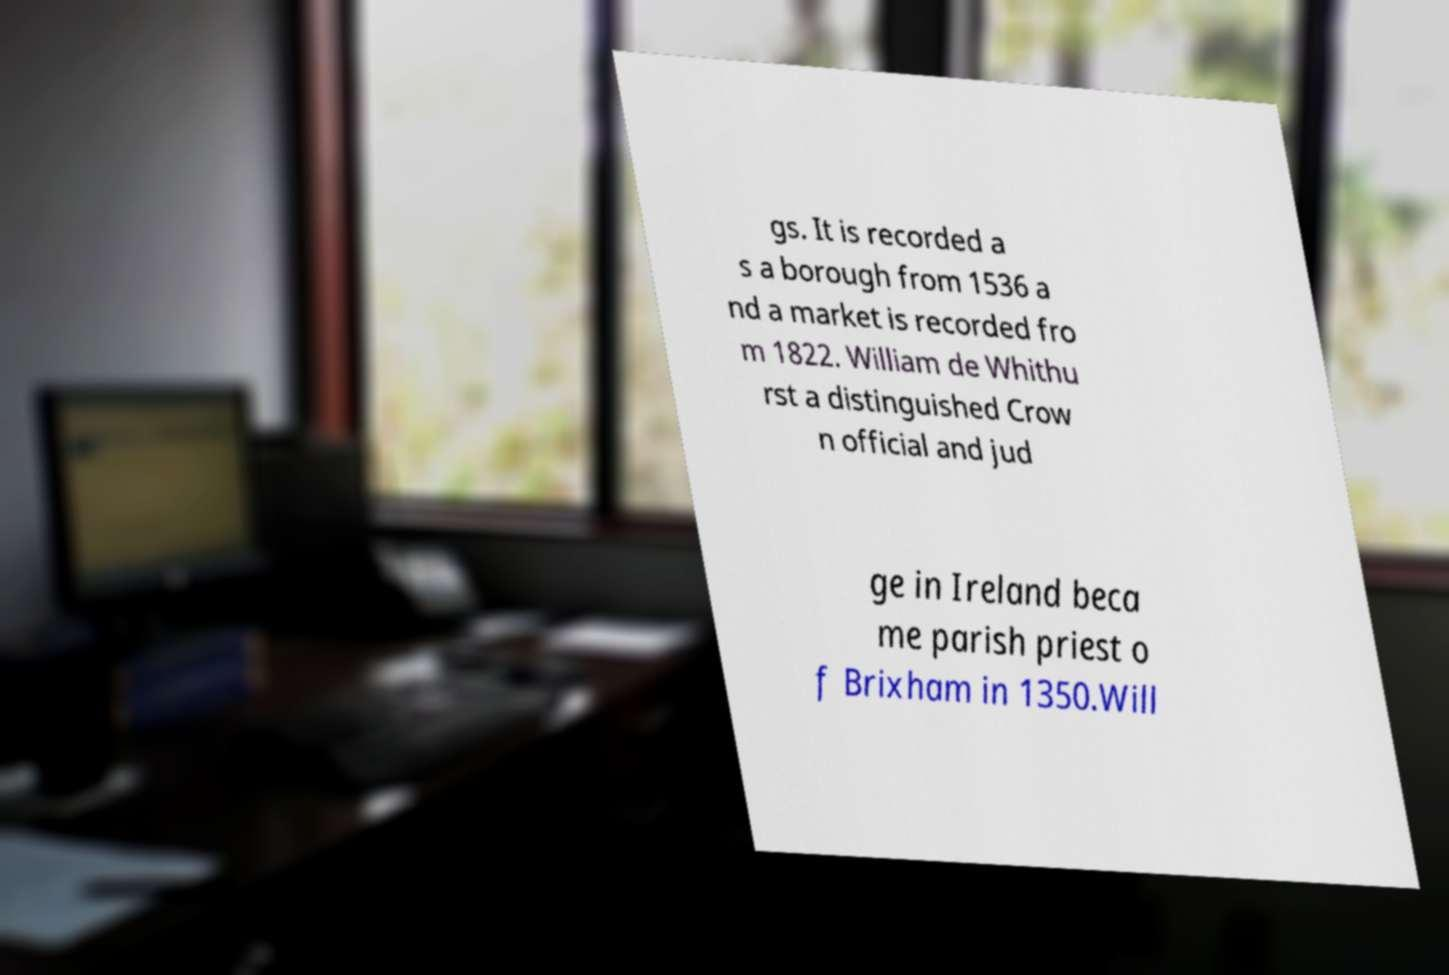I need the written content from this picture converted into text. Can you do that? gs. It is recorded a s a borough from 1536 a nd a market is recorded fro m 1822. William de Whithu rst a distinguished Crow n official and jud ge in Ireland beca me parish priest o f Brixham in 1350.Will 